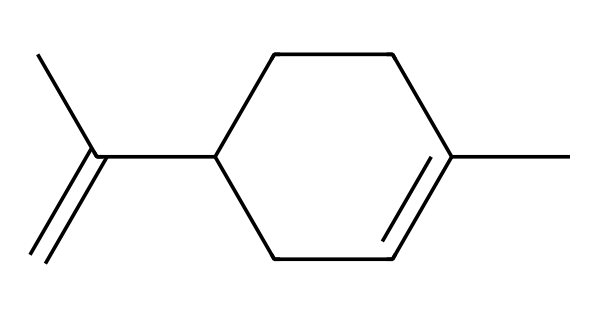What is the molecular formula of limonene? To determine the molecular formula, count the number of carbon (C) and hydrogen (H) atoms in the given SMILES. The structure contains 10 carbon atoms and 16 hydrogen atoms, leading to the formula C10H16.
Answer: C10H16 How many rings are present in the structure of limonene? By analyzing the SMILES representation, we note that there is a cyclohexene unit (indicated by C1=CCC(CC1)), which is a ring structure. Thus, there is one ring present in limonene.
Answer: 1 What type of hybridization do the carbon atoms in limonene primarily exhibit? The carbon atoms involved in double bonds and those in the cycloalkane show sp2 hybridization due to the presence of double bonds. The remaining carbon atoms in the chain exhibit sp3 hybridization.
Answer: sp2 and sp3 Which functional group is present in limonene's structure? Limonene does not have a typical functional group like alcohols or acids; instead, it contains a double bond (alkene). Thus, the alkene functional group is present.
Answer: alkene Is limonene a saturated or unsaturated compound? Given that limonene has a carbon-carbon double bond, it lacks the maximum number of hydrogen atoms for its carbon skeleton, classifying it as an unsaturated compound.
Answer: unsaturated Does limonene contain any chiral centers? Looking through the structure, there are two carbon atoms where different groups are attached, indicating that they are chiral centers. Thus, limonene has two chiral centers.
Answer: 2 